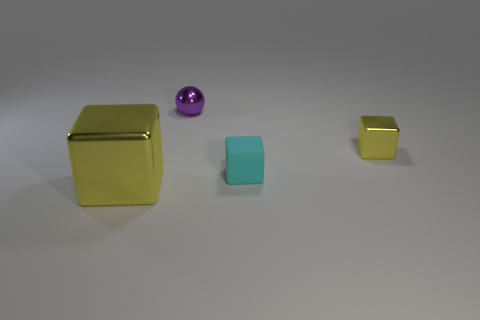What number of metal spheres are the same color as the small matte block?
Provide a short and direct response. 0. Is there a yellow object?
Make the answer very short. Yes. Is the shape of the large yellow object the same as the yellow metallic thing that is behind the matte object?
Keep it short and to the point. Yes. What color is the cube in front of the tiny object that is in front of the yellow metallic block that is behind the cyan object?
Your response must be concise. Yellow. Are there any tiny shiny objects on the right side of the purple thing?
Offer a terse response. Yes. What size is the other shiny thing that is the same color as the large object?
Provide a succinct answer. Small. Is there a tiny yellow cube made of the same material as the ball?
Your answer should be compact. Yes. The big metallic thing has what color?
Your answer should be compact. Yellow. Do the yellow object on the left side of the tiny purple object and the purple shiny object have the same shape?
Give a very brief answer. No. There is a metal thing that is behind the yellow block on the right side of the big thing that is to the left of the purple sphere; what is its shape?
Your answer should be very brief. Sphere. 